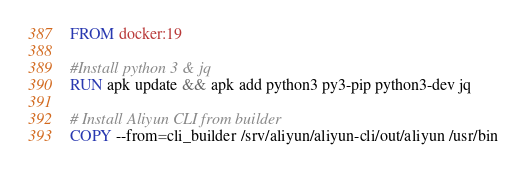<code> <loc_0><loc_0><loc_500><loc_500><_Dockerfile_>
FROM docker:19

#Install python 3 & jq
RUN apk update && apk add python3 py3-pip python3-dev jq

# Install Aliyun CLI from builder
COPY --from=cli_builder /srv/aliyun/aliyun-cli/out/aliyun /usr/bin
</code> 